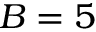<formula> <loc_0><loc_0><loc_500><loc_500>B = 5</formula> 